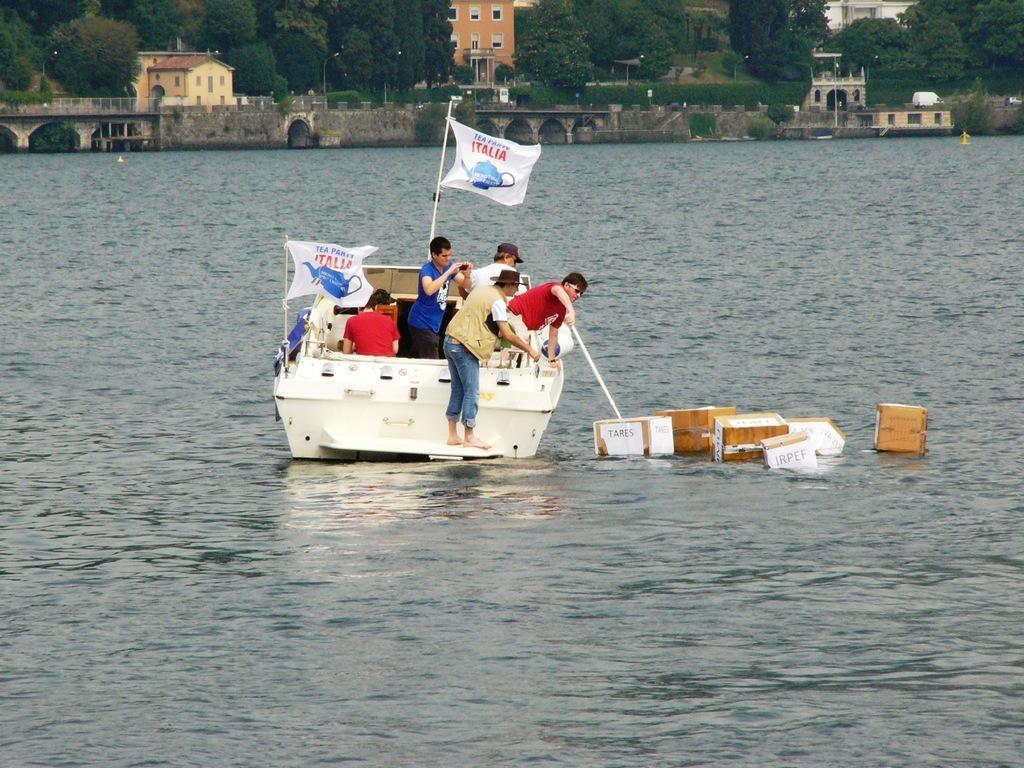Could you give a brief overview of what you see in this image? In this picture I can see a boat on the water, there are flags and group of people standing on the boat, there are wooden objects floating on the water, and in the background there are houses, poles, trees and a bridge. 